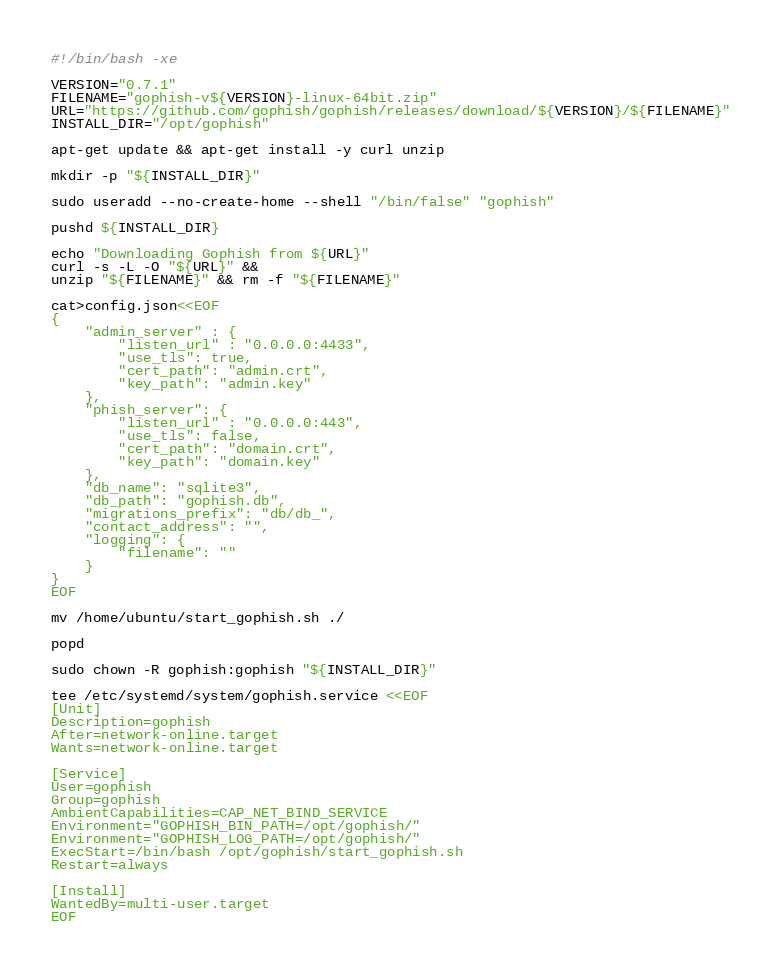<code> <loc_0><loc_0><loc_500><loc_500><_Bash_>#!/bin/bash -xe

VERSION="0.7.1"
FILENAME="gophish-v${VERSION}-linux-64bit.zip"
URL="https://github.com/gophish/gophish/releases/download/${VERSION}/${FILENAME}"
INSTALL_DIR="/opt/gophish"

apt-get update && apt-get install -y curl unzip

mkdir -p "${INSTALL_DIR}"

sudo useradd --no-create-home --shell "/bin/false" "gophish"

pushd ${INSTALL_DIR}

echo "Downloading Gophish from ${URL}"
curl -s -L -O "${URL}" &&
unzip "${FILENAME}" && rm -f "${FILENAME}"

cat>config.json<<EOF
{
    "admin_server" : {
        "listen_url" : "0.0.0.0:4433",
        "use_tls": true,
        "cert_path": "admin.crt",
        "key_path": "admin.key"
    },
    "phish_server": {
        "listen_url" : "0.0.0.0:443",
        "use_tls": false,
        "cert_path": "domain.crt",
        "key_path": "domain.key"
    },
    "db_name": "sqlite3",
	"db_path": "gophish.db",
	"migrations_prefix": "db/db_",
	"contact_address": "",
	"logging": {
		"filename": ""
	}
}
EOF

mv /home/ubuntu/start_gophish.sh ./

popd

sudo chown -R gophish:gophish "${INSTALL_DIR}"

tee /etc/systemd/system/gophish.service <<EOF
[Unit]
Description=gophish
After=network-online.target
Wants=network-online.target

[Service]
User=gophish
Group=gophish
AmbientCapabilities=CAP_NET_BIND_SERVICE
Environment="GOPHISH_BIN_PATH=/opt/gophish/"
Environment="GOPHISH_LOG_PATH=/opt/gophish/"
ExecStart=/bin/bash /opt/gophish/start_gophish.sh
Restart=always

[Install]
WantedBy=multi-user.target
EOF</code> 